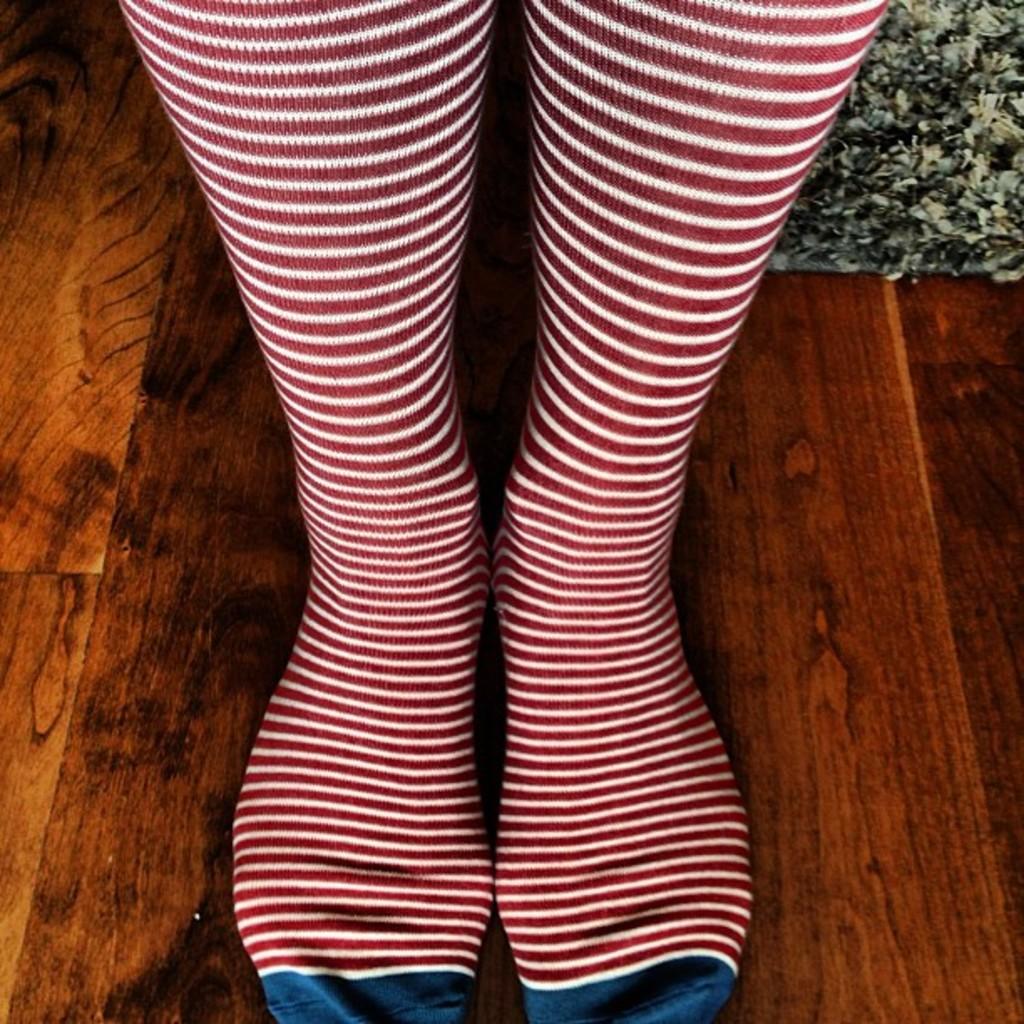Can you describe this image briefly? In this image, we can see the legs of a person on the wooden surface. We can also see an object in the top right corner. 